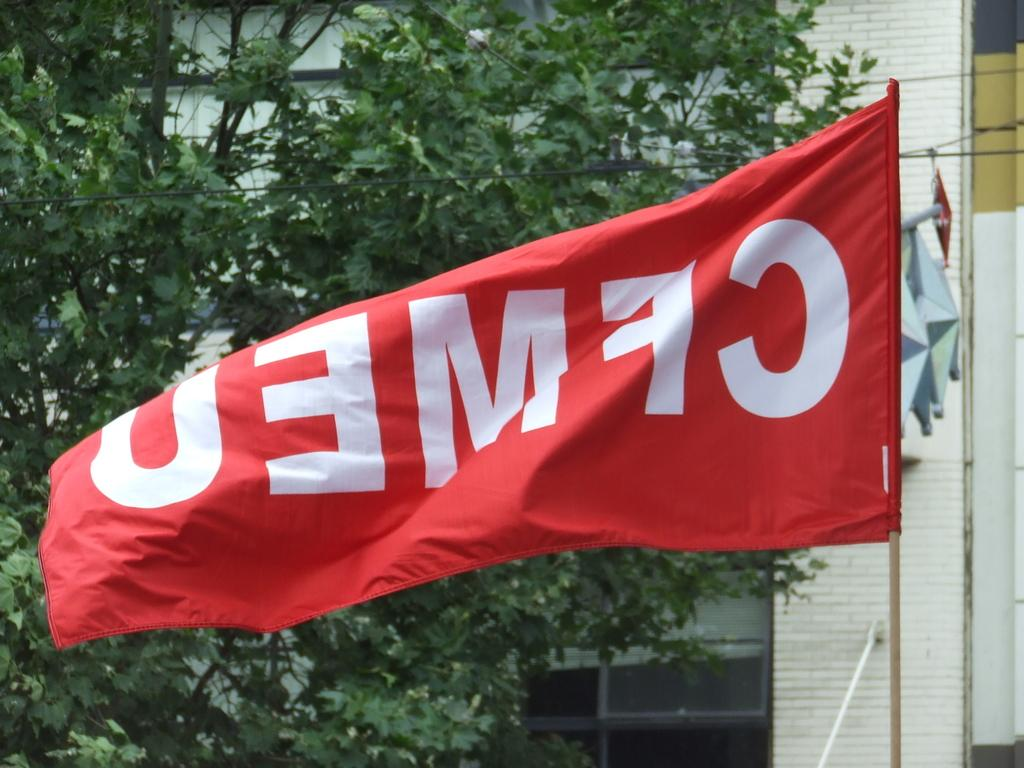What can be seen flying in the image? There are no objects flying in the image; the focus is on the flags, trees, and building. What type of natural elements are present in the image? Trees are present in the image. What type of structure can be seen in the background of the image? There is a building in the background of the image. What is the person in the image watching? There is no person present in the image, so it is not possible to determine what they might be watching. 